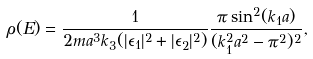<formula> <loc_0><loc_0><loc_500><loc_500>\rho ( E ) = \frac { 1 } { 2 m a ^ { 3 } k _ { 3 } ( | \epsilon _ { 1 } | ^ { 2 } + | \epsilon _ { 2 } | ^ { 2 } ) } \frac { \pi \sin ^ { 2 } ( k _ { 1 } a ) } { ( k _ { 1 } ^ { 2 } a ^ { 2 } - \pi ^ { 2 } ) ^ { 2 } } ,</formula> 